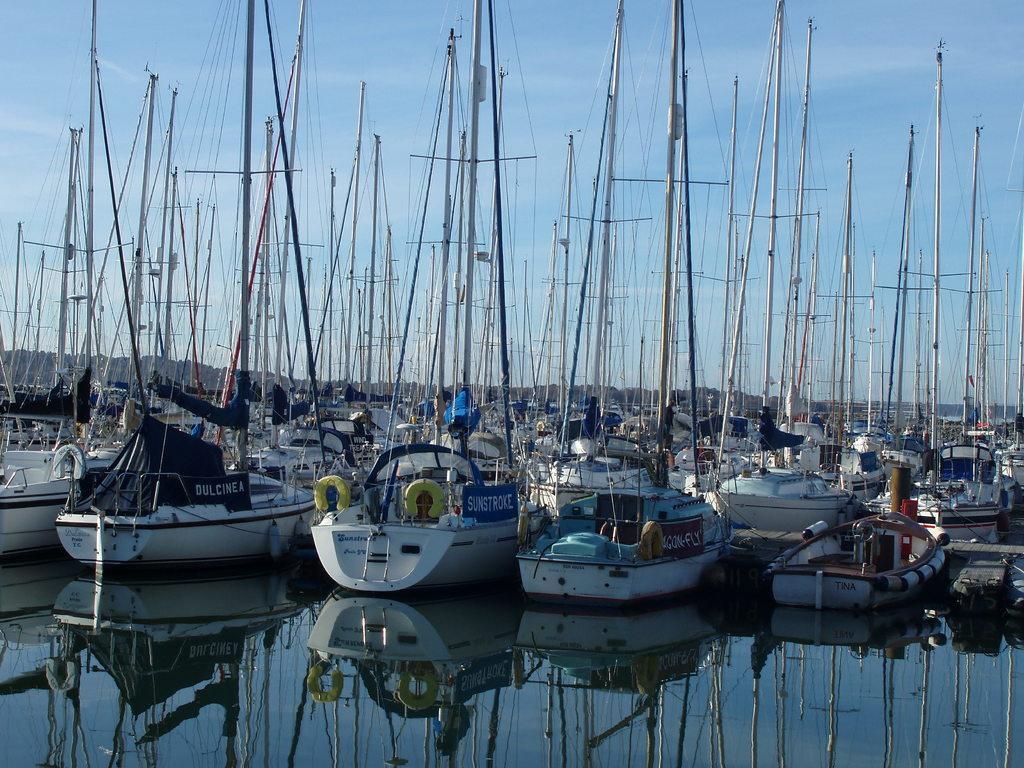Could you give a brief overview of what you see in this image? In this image we can see the mountains, the harbor, some boats on the water, some poles, some objects in the boats, some banners with text attached to the boats and at the top there is the sky. 